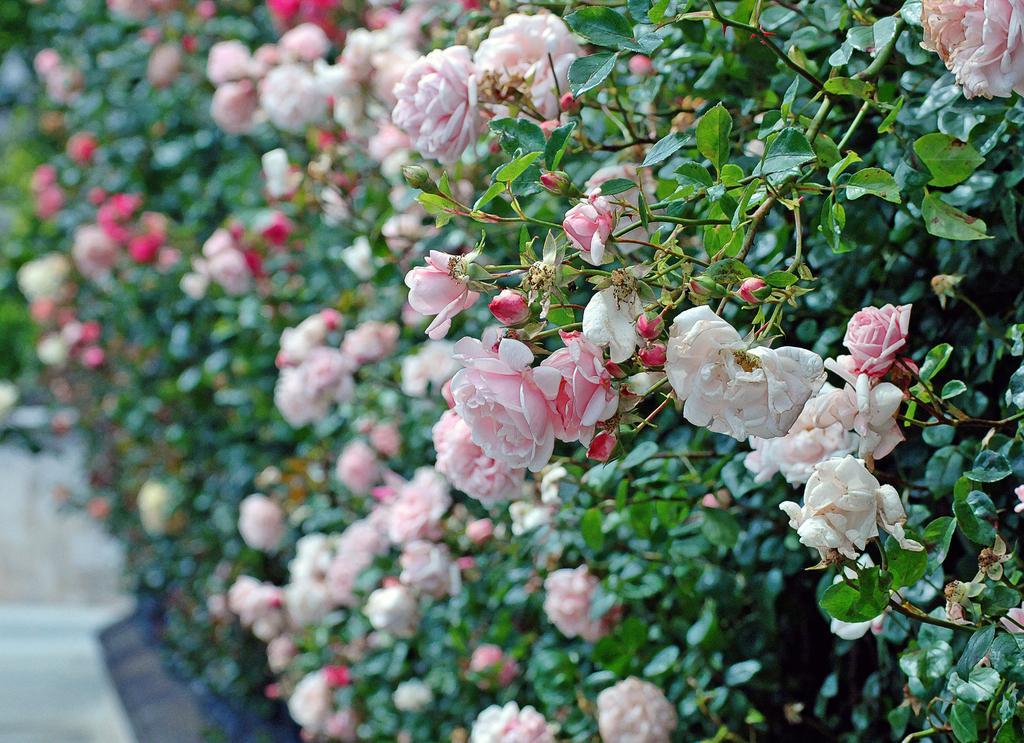How would you summarize this image in a sentence or two? This picture is clicked outside. In the foreground we can see the flowers and the green leaves of the trees. On the left we can see the ground like thing and we can see some objects. 